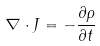Convert formula to latex. <formula><loc_0><loc_0><loc_500><loc_500>\nabla \cdot J = - { \frac { \partial \rho } { \partial t } }</formula> 